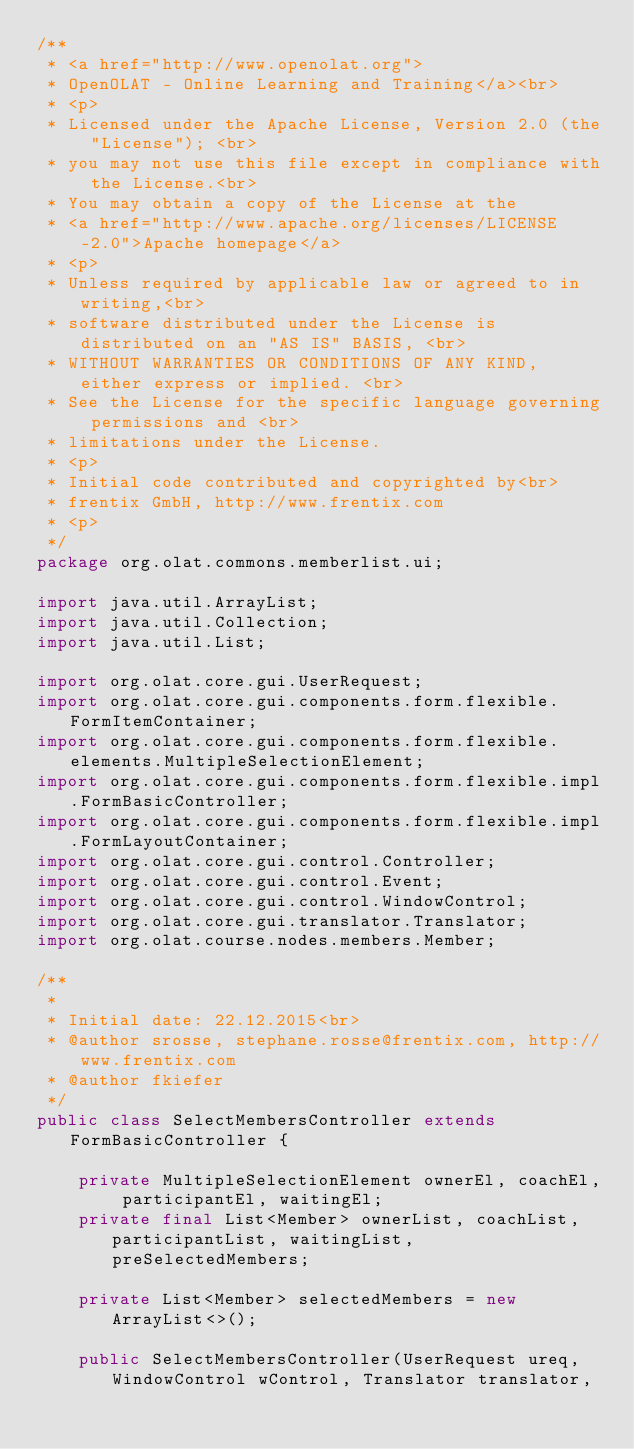Convert code to text. <code><loc_0><loc_0><loc_500><loc_500><_Java_>/**
 * <a href="http://www.openolat.org">
 * OpenOLAT - Online Learning and Training</a><br>
 * <p>
 * Licensed under the Apache License, Version 2.0 (the "License"); <br>
 * you may not use this file except in compliance with the License.<br>
 * You may obtain a copy of the License at the
 * <a href="http://www.apache.org/licenses/LICENSE-2.0">Apache homepage</a>
 * <p>
 * Unless required by applicable law or agreed to in writing,<br>
 * software distributed under the License is distributed on an "AS IS" BASIS, <br>
 * WITHOUT WARRANTIES OR CONDITIONS OF ANY KIND, either express or implied. <br>
 * See the License for the specific language governing permissions and <br>
 * limitations under the License.
 * <p>
 * Initial code contributed and copyrighted by<br>
 * frentix GmbH, http://www.frentix.com
 * <p>
 */
package org.olat.commons.memberlist.ui;

import java.util.ArrayList;
import java.util.Collection;
import java.util.List;

import org.olat.core.gui.UserRequest;
import org.olat.core.gui.components.form.flexible.FormItemContainer;
import org.olat.core.gui.components.form.flexible.elements.MultipleSelectionElement;
import org.olat.core.gui.components.form.flexible.impl.FormBasicController;
import org.olat.core.gui.components.form.flexible.impl.FormLayoutContainer;
import org.olat.core.gui.control.Controller;
import org.olat.core.gui.control.Event;
import org.olat.core.gui.control.WindowControl;
import org.olat.core.gui.translator.Translator;
import org.olat.course.nodes.members.Member;

/**
 * 
 * Initial date: 22.12.2015<br>
 * @author srosse, stephane.rosse@frentix.com, http://www.frentix.com
 * @author fkiefer
 */
public class SelectMembersController extends FormBasicController {

	private MultipleSelectionElement ownerEl, coachEl, participantEl, waitingEl;
	private final List<Member> ownerList, coachList, participantList, waitingList, preSelectedMembers;
	
	private List<Member> selectedMembers = new ArrayList<>();
	
	public SelectMembersController(UserRequest ureq, WindowControl wControl, Translator translator,</code> 